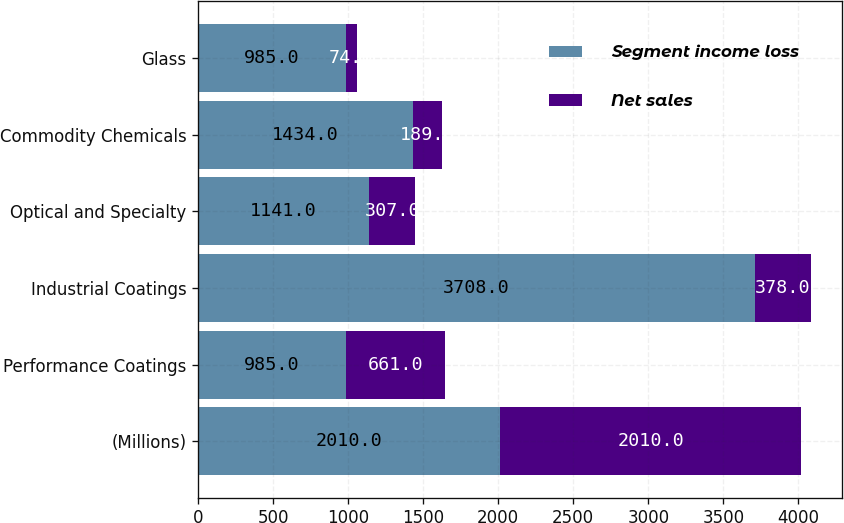Convert chart. <chart><loc_0><loc_0><loc_500><loc_500><stacked_bar_chart><ecel><fcel>(Millions)<fcel>Performance Coatings<fcel>Industrial Coatings<fcel>Optical and Specialty<fcel>Commodity Chemicals<fcel>Glass<nl><fcel>Segment income loss<fcel>2010<fcel>985<fcel>3708<fcel>1141<fcel>1434<fcel>985<nl><fcel>Net sales<fcel>2010<fcel>661<fcel>378<fcel>307<fcel>189<fcel>74<nl></chart> 